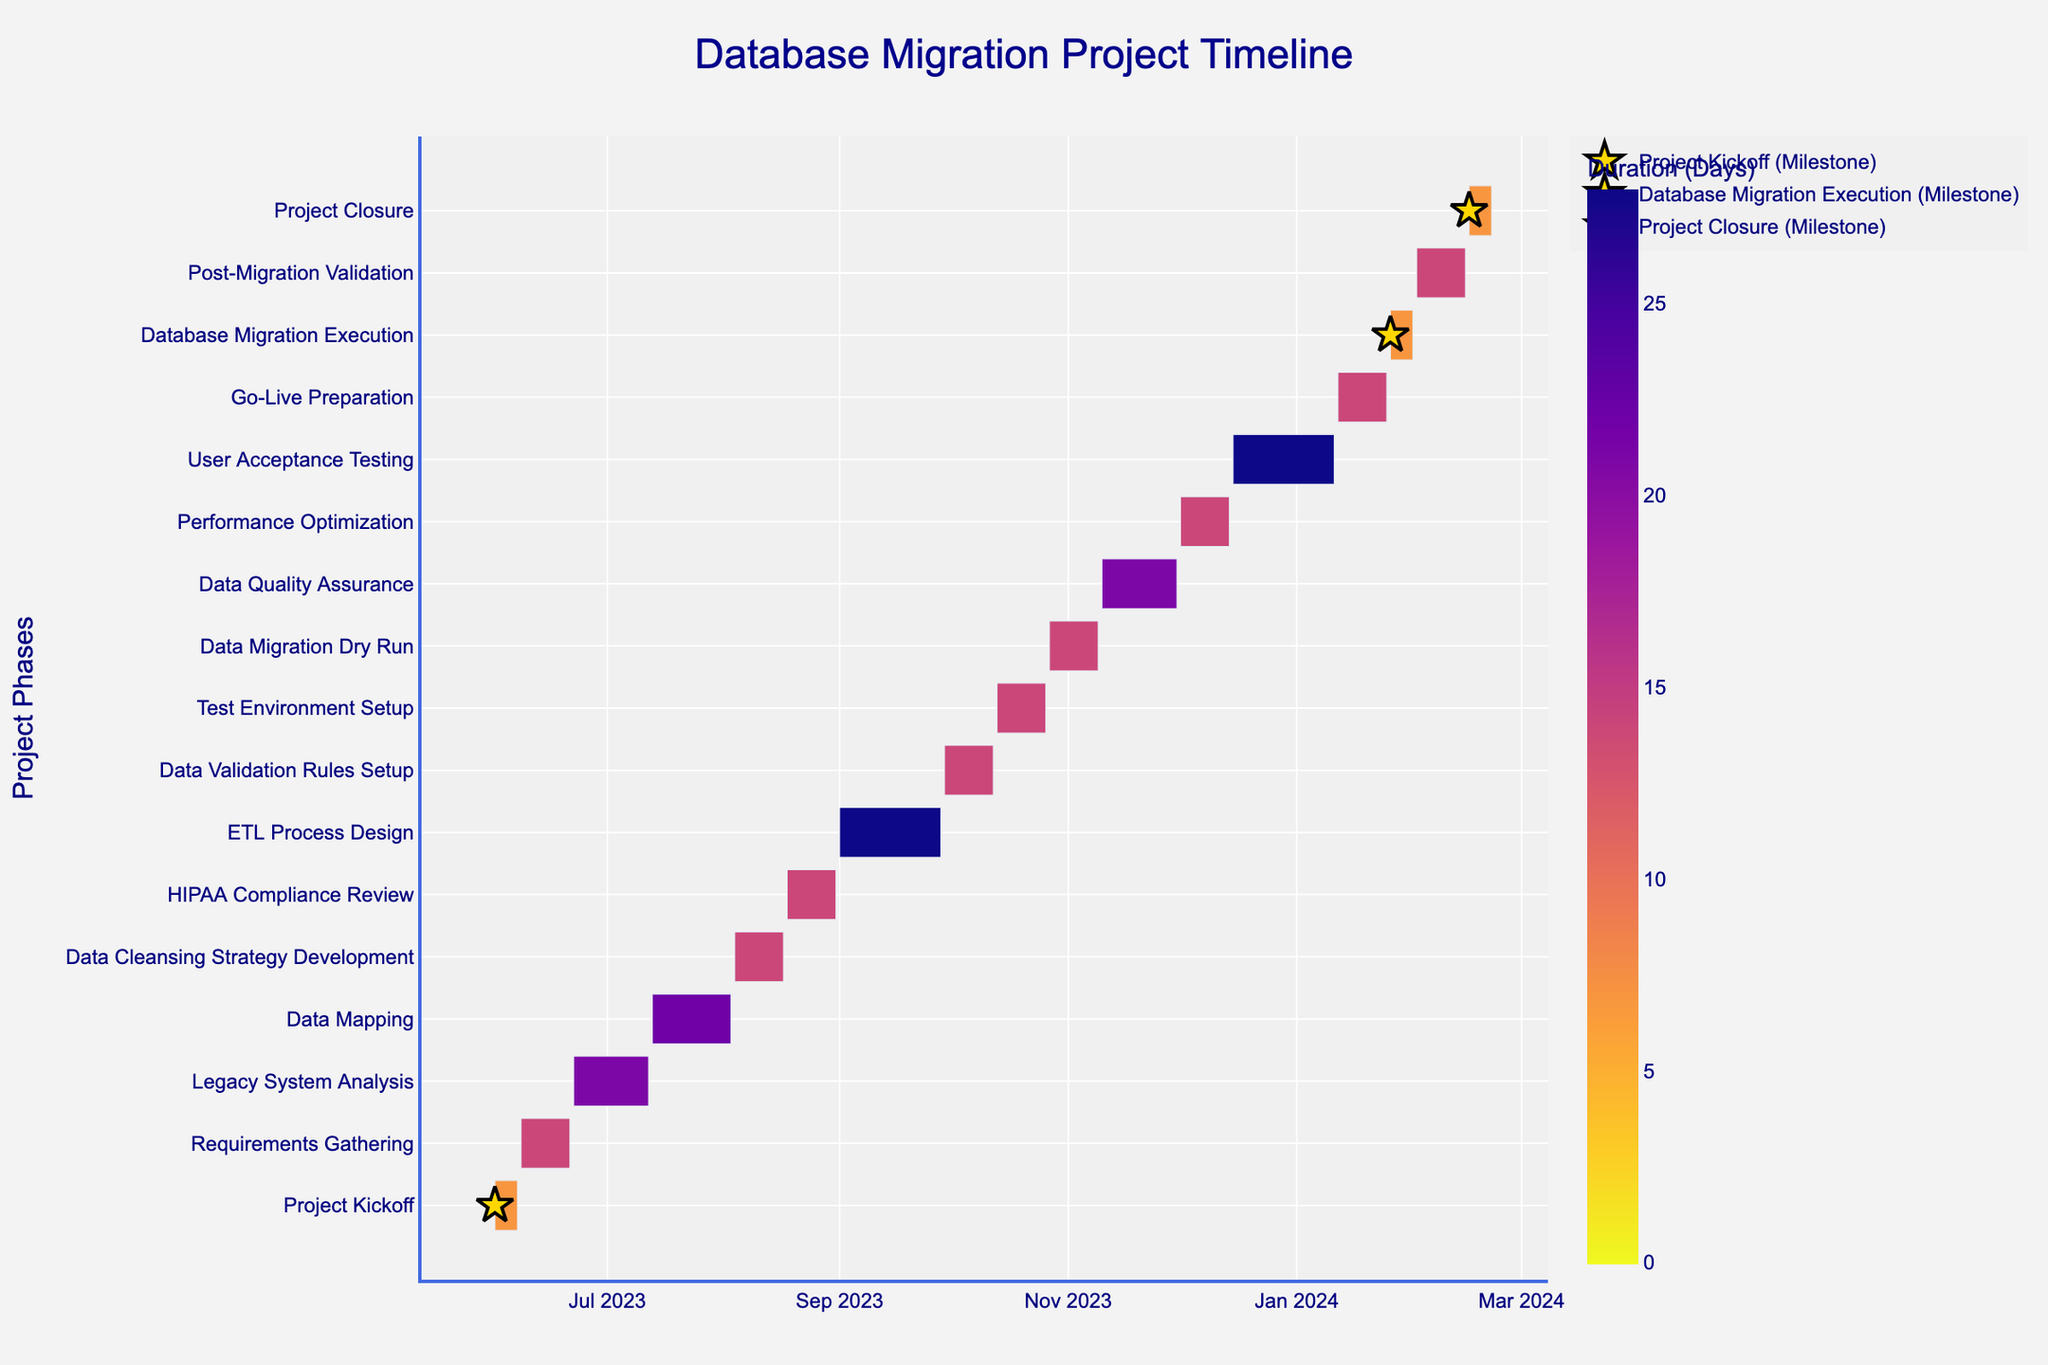What's the title of the chart? The title of the chart is prominently displayed at the top and reads "Database Migration Project Timeline".
Answer: Database Migration Project Timeline Which task lasts the longest in the project? By observing the duration of the bars in the chart and referring to the color scale for duration, the task “ETL Process Design” with 28 days appears to be the longest.
Answer: ETL Process Design How many tasks have a duration of exactly 14 days? By reviewing the color-coded durations on the Gantt chart, there are several tasks with a duration of 14 days: Project Kickoff, Requirements Gathering, Data Cleansing Strategy Development, HIPAA Compliance Review, Data Validation Rules Setup, Test Environment Setup, Data Migration Dry Run, Performance Optimization, Go-Live Preparation, Post-Migration Validation, and Project Closure. Counting these gives us 11 tasks.
Answer: 11 Which task directly follows “Data Mapping”? Looking at the sequence of tasks, the one immediately after “Data Mapping” is “Data Cleansing Strategy Development”.
Answer: Data Cleansing Strategy Development What are the milestone tasks highlighted on the chart? Reviewing the special markers (stars) on the chart indicates milestones for “Project Kickoff”, “Database Migration Execution”, and “Project Closure”.
Answer: Project Kickoff, Database Migration Execution, Project Closure Does the data migration dry run occur before or after the data validation rules setup? The timelines for both tasks show that "Data Validation Rules Setup" ends on 2023-10-12 and "Data Migration Dry Run" starts on 2023-10-27, indicating the dry run occurs after the setup.
Answer: After Compare the duration of “Data Quality Assurance” and “Performance Optimization”. Which is longer and by how many days? "Data Quality Assurance" has a duration of 21 days while "Performance Optimization" has 14 days. The difference (21 - 14) is 7 days.
Answer: Data Quality Assurance by 7 days What's the total duration of all tasks combined? Summing up the durations of all listed tasks: 7 + 14 + 21 + 22 + 14 + 14 + 28 + 14 + 14 + 14 + 21 + 14 + 28 + 14 + 7 + 14 + 7 = 278 days.
Answer: 278 days When does user acceptance testing start and end? User acceptance testing is shown to start on 2023-12-15 and end on 2024-01-11 in the timeline.
Answer: 2023-12-15 to 2024-01-11 